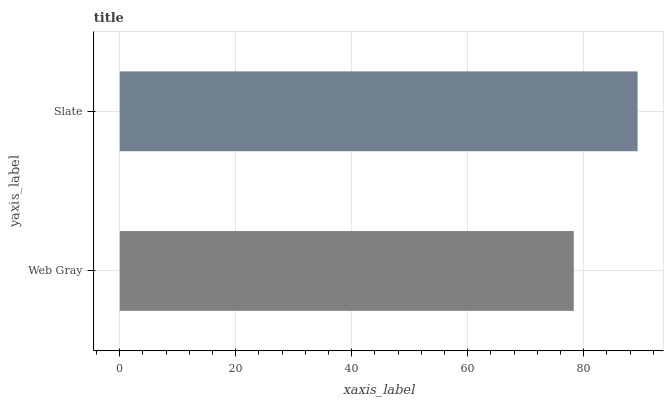Is Web Gray the minimum?
Answer yes or no. Yes. Is Slate the maximum?
Answer yes or no. Yes. Is Slate the minimum?
Answer yes or no. No. Is Slate greater than Web Gray?
Answer yes or no. Yes. Is Web Gray less than Slate?
Answer yes or no. Yes. Is Web Gray greater than Slate?
Answer yes or no. No. Is Slate less than Web Gray?
Answer yes or no. No. Is Slate the high median?
Answer yes or no. Yes. Is Web Gray the low median?
Answer yes or no. Yes. Is Web Gray the high median?
Answer yes or no. No. Is Slate the low median?
Answer yes or no. No. 